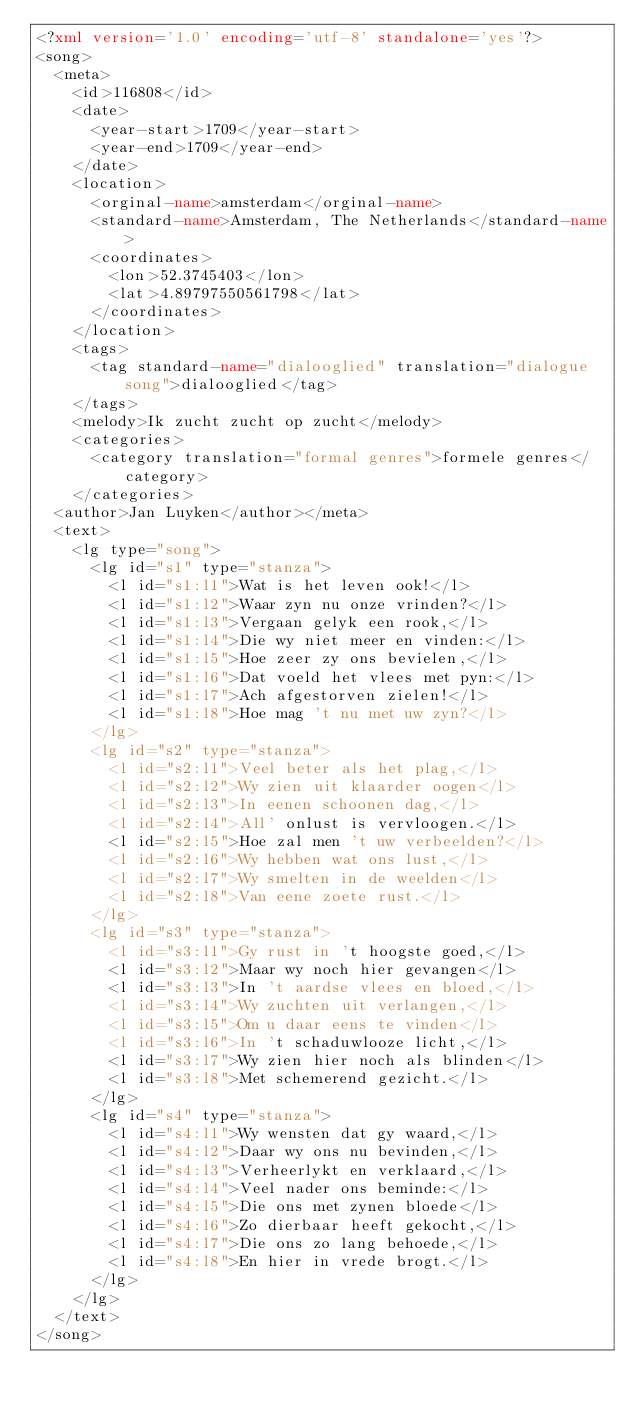Convert code to text. <code><loc_0><loc_0><loc_500><loc_500><_XML_><?xml version='1.0' encoding='utf-8' standalone='yes'?>
<song>
  <meta>
    <id>116808</id>
    <date>
      <year-start>1709</year-start>
      <year-end>1709</year-end>
    </date>
    <location>
      <orginal-name>amsterdam</orginal-name>
      <standard-name>Amsterdam, The Netherlands</standard-name>
      <coordinates>
        <lon>52.3745403</lon>
        <lat>4.89797550561798</lat>
      </coordinates>
    </location>
    <tags>
      <tag standard-name="dialooglied" translation="dialogue song">dialooglied</tag>
    </tags>
    <melody>Ik zucht zucht op zucht</melody>
    <categories>
      <category translation="formal genres">formele genres</category>
    </categories>
  <author>Jan Luyken</author></meta>
  <text>
    <lg type="song">
      <lg id="s1" type="stanza">
        <l id="s1:l1">Wat is het leven ook!</l>
        <l id="s1:l2">Waar zyn nu onze vrinden?</l>
        <l id="s1:l3">Vergaan gelyk een rook,</l>
        <l id="s1:l4">Die wy niet meer en vinden:</l>
        <l id="s1:l5">Hoe zeer zy ons bevielen,</l>
        <l id="s1:l6">Dat voeld het vlees met pyn:</l>
        <l id="s1:l7">Ach afgestorven zielen!</l>
        <l id="s1:l8">Hoe mag 't nu met uw zyn?</l>
      </lg>
      <lg id="s2" type="stanza">
        <l id="s2:l1">Veel beter als het plag,</l>
        <l id="s2:l2">Wy zien uit klaarder oogen</l>
        <l id="s2:l3">In eenen schoonen dag,</l>
        <l id="s2:l4">All' onlust is vervloogen.</l>
        <l id="s2:l5">Hoe zal men 't uw verbeelden?</l>
        <l id="s2:l6">Wy hebben wat ons lust,</l>
        <l id="s2:l7">Wy smelten in de weelden</l>
        <l id="s2:l8">Van eene zoete rust.</l>
      </lg>
      <lg id="s3" type="stanza">
        <l id="s3:l1">Gy rust in 't hoogste goed,</l>
        <l id="s3:l2">Maar wy noch hier gevangen</l>
        <l id="s3:l3">In 't aardse vlees en bloed,</l>
        <l id="s3:l4">Wy zuchten uit verlangen,</l>
        <l id="s3:l5">Om u daar eens te vinden</l>
        <l id="s3:l6">In 't schaduwlooze licht,</l>
        <l id="s3:l7">Wy zien hier noch als blinden</l>
        <l id="s3:l8">Met schemerend gezicht.</l>
      </lg>
      <lg id="s4" type="stanza">
        <l id="s4:l1">Wy wensten dat gy waard,</l>
        <l id="s4:l2">Daar wy ons nu bevinden,</l>
        <l id="s4:l3">Verheerlykt en verklaard,</l>
        <l id="s4:l4">Veel nader ons beminde:</l>
        <l id="s4:l5">Die ons met zynen bloede</l>
        <l id="s4:l6">Zo dierbaar heeft gekocht,</l>
        <l id="s4:l7">Die ons zo lang behoede,</l>
        <l id="s4:l8">En hier in vrede brogt.</l>
      </lg>
    </lg>
  </text>
</song>
</code> 